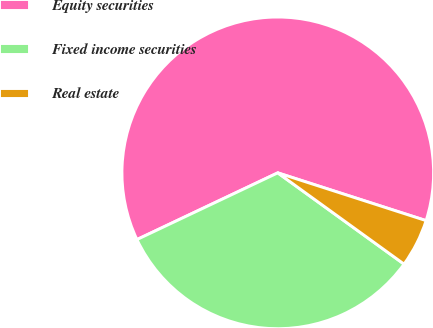Convert chart to OTSL. <chart><loc_0><loc_0><loc_500><loc_500><pie_chart><fcel>Equity securities<fcel>Fixed income securities<fcel>Real estate<nl><fcel>62.0%<fcel>33.0%<fcel>5.0%<nl></chart> 